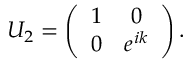Convert formula to latex. <formula><loc_0><loc_0><loc_500><loc_500>U _ { 2 } = \left ( \begin{array} { c c } { 1 } & { 0 } \\ { 0 } & { e ^ { i k } } \end{array} \right ) .</formula> 